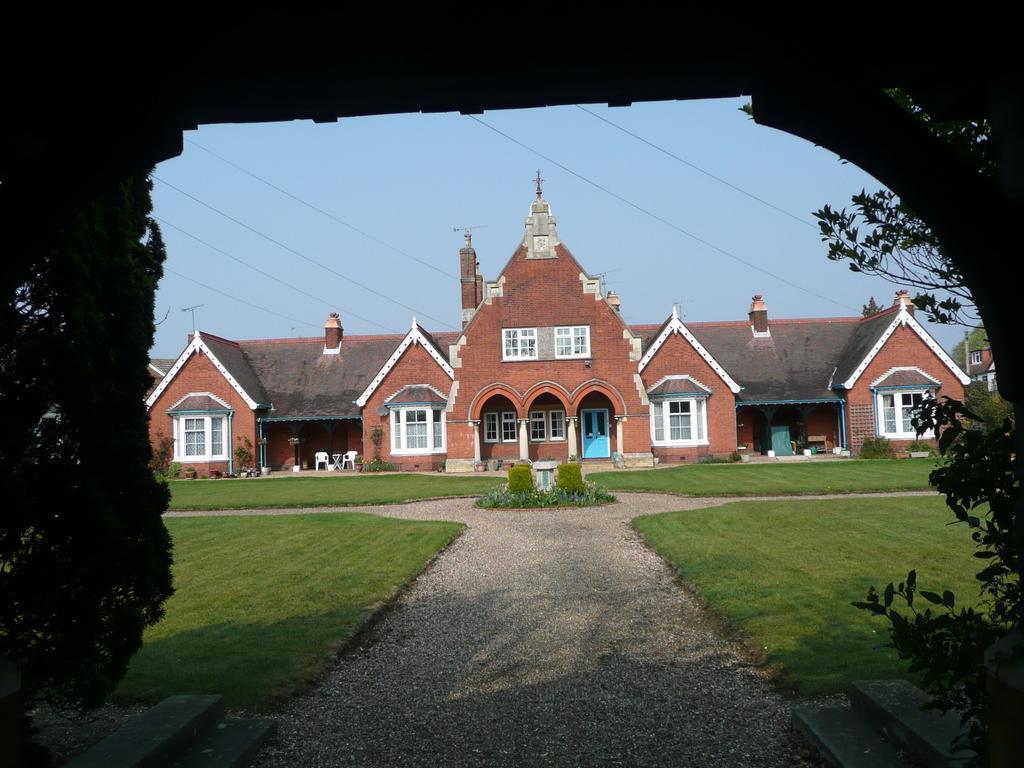How would you summarize this image in a sentence or two? In this picture we can see an arch, trees, buildings with windows, chairs, grass and in the background we can see the sky. 